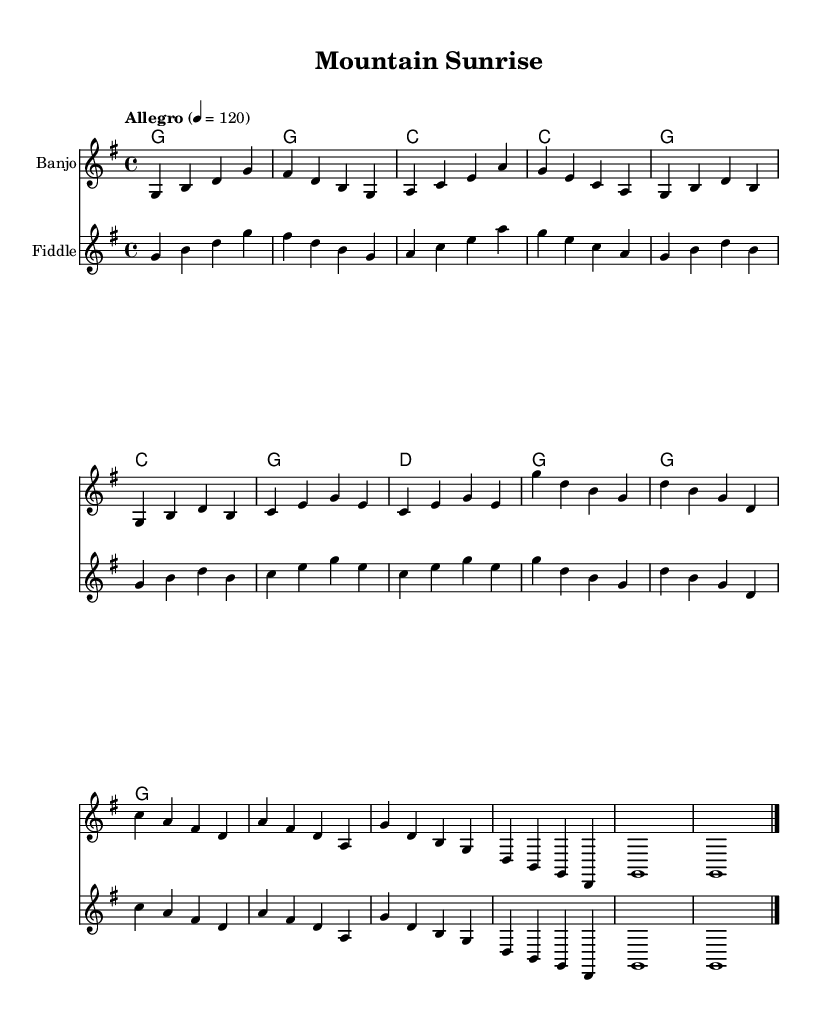What is the key signature of this music? The key signature is G major, which includes one sharp (F sharp). This can be identified from the beginning of the sheet music where the key is notated.
Answer: G major What is the time signature? The time signature is 4/4, indicated at the start of the score. This signifies that each measure contains four beats and that a quarter note receives one beat.
Answer: 4/4 What is the tempo marking of the piece? The tempo marking indicates "Allegro" with a tempo of quarter note equals 120. This suggests a lively and fast pace for the piece. This information is stated next to the time signature at the beginning of the sheet music.
Answer: Allegro 4 = 120 How many measures are in the intro section? The intro consists of four measures as seen in the first line of the banjo and fiddle parts. Each measure is defined by the vertical bar lines, and counting them gives a total of four.
Answer: 4 What are the instruments featured in this sheet music? The instruments featured are the Banjo and Fiddle. This can be identified by the instrument names placed at the beginning of their respective staff lines in the score.
Answer: Banjo, Fiddle What chords are used in the chorus section? The chords used in the chorus are G, D, and C. These can be identified in the chord representation section, where the progression for the chorus happens in the second half of the music.
Answer: G, D, C 